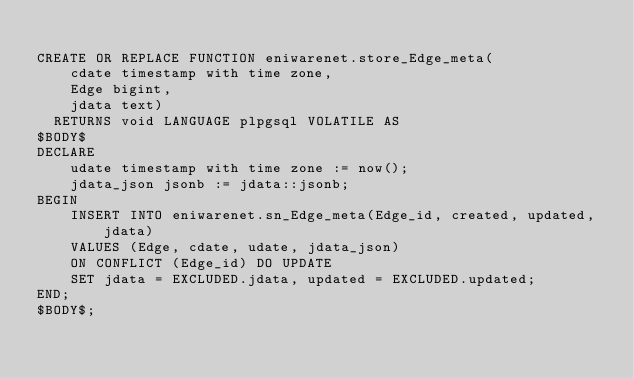Convert code to text. <code><loc_0><loc_0><loc_500><loc_500><_SQL_>
CREATE OR REPLACE FUNCTION eniwarenet.store_Edge_meta(
	cdate timestamp with time zone,
	Edge bigint,
	jdata text)
  RETURNS void LANGUAGE plpgsql VOLATILE AS
$BODY$
DECLARE
	udate timestamp with time zone := now();
	jdata_json jsonb := jdata::jsonb;
BEGIN
	INSERT INTO eniwarenet.sn_Edge_meta(Edge_id, created, updated, jdata)
	VALUES (Edge, cdate, udate, jdata_json)
	ON CONFLICT (Edge_id) DO UPDATE
	SET jdata = EXCLUDED.jdata, updated = EXCLUDED.updated;
END;
$BODY$;
</code> 